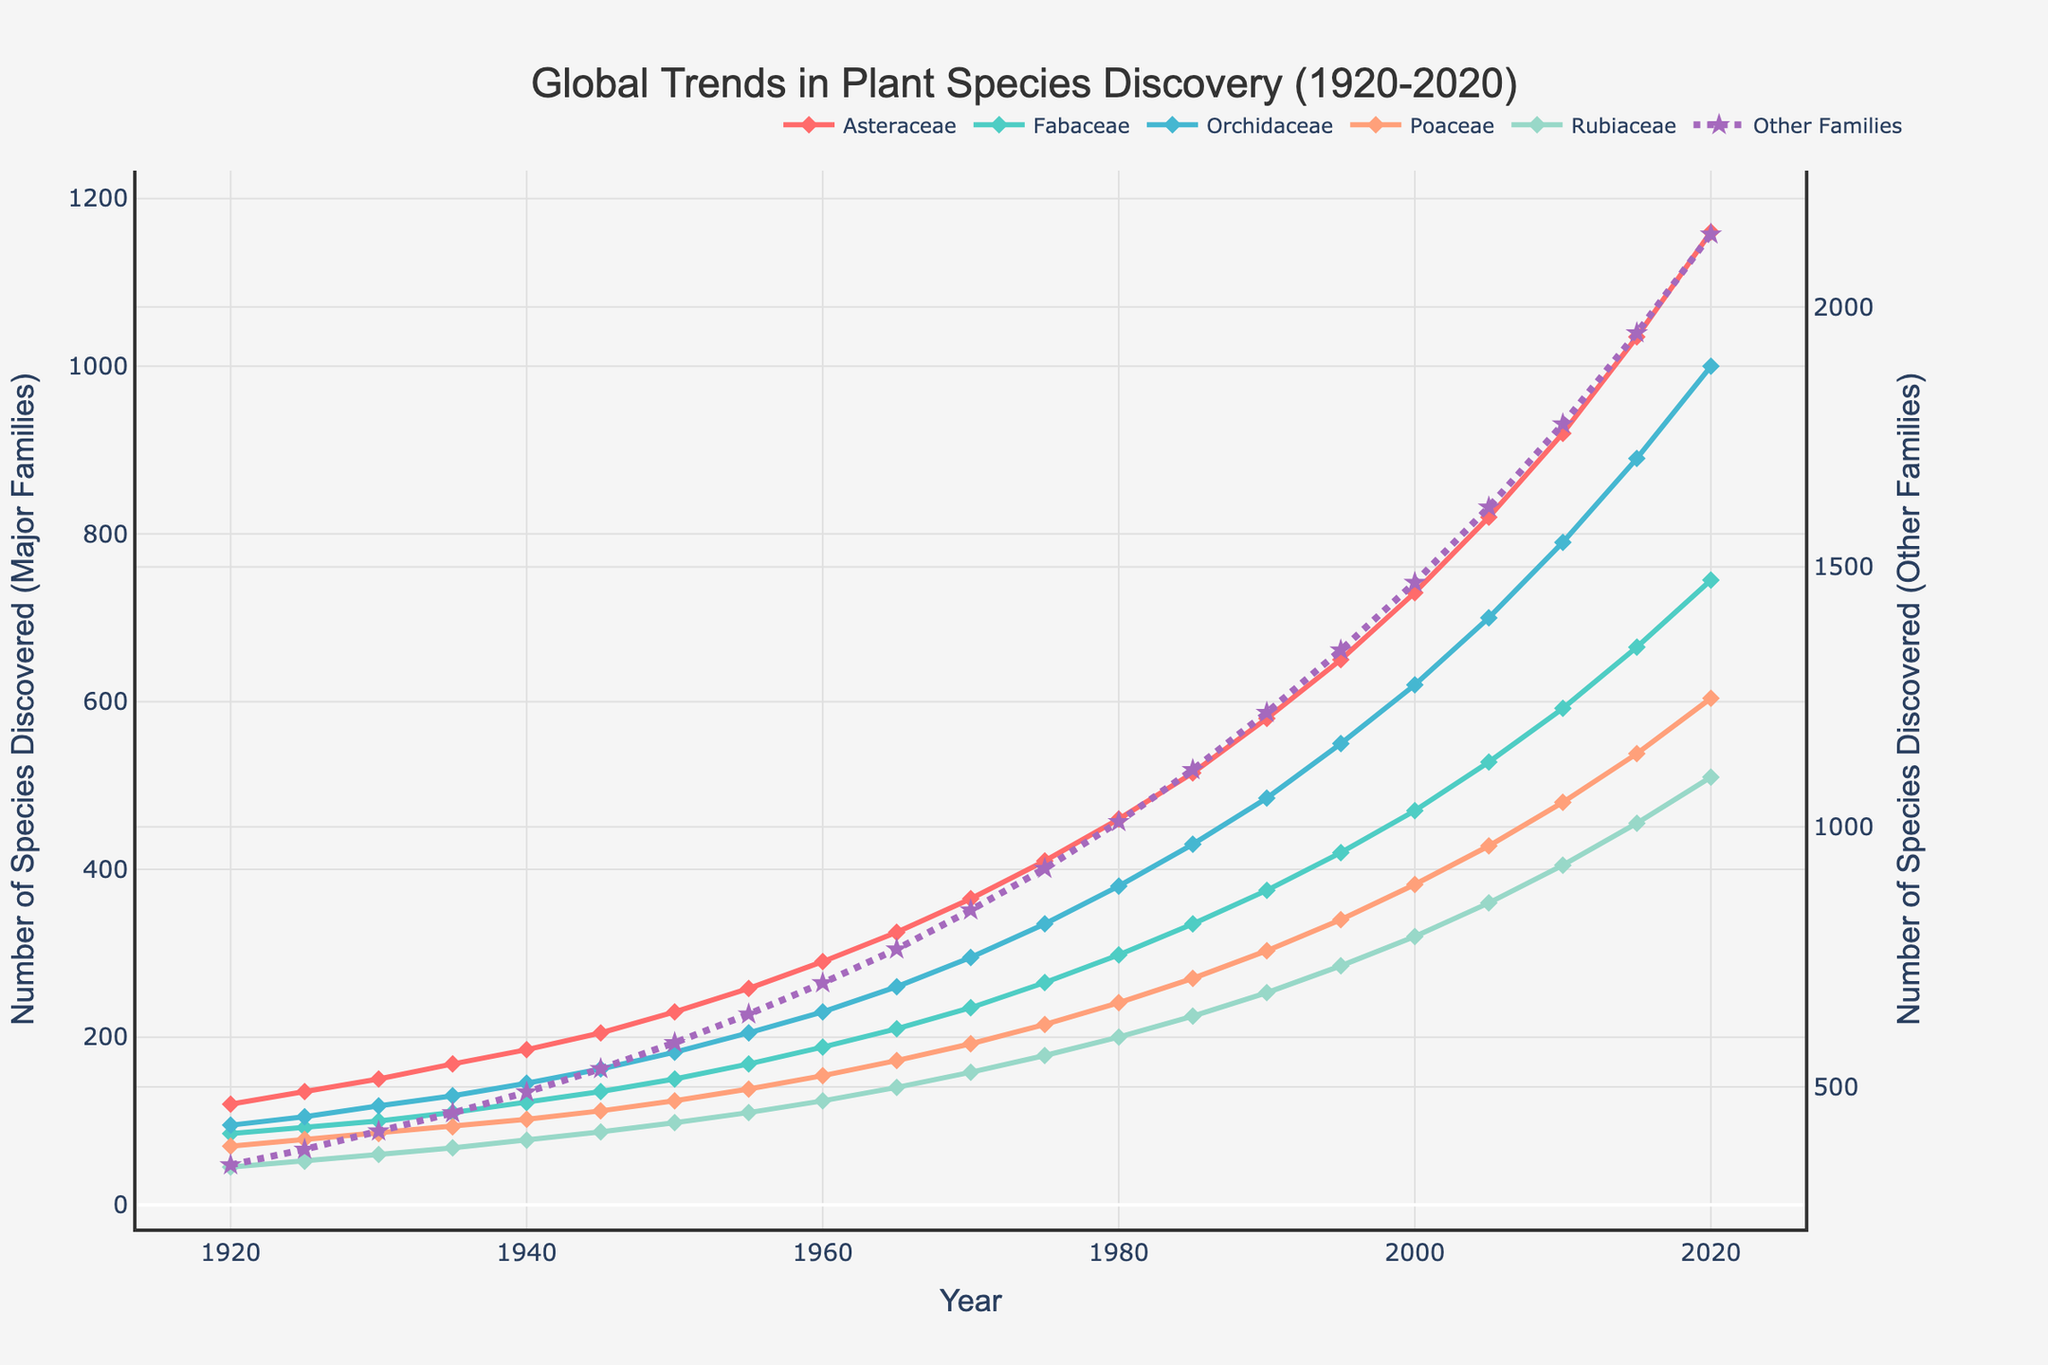What is the trend of species discovery for the Asteraceae family from 1920 to 2020? To find the trend, look at the plotted line for the Asteraceae family. The number of species discovered starts at 120 in 1920 and rises steadily to 1160 in 2020, indicating a consistent upward trend in discoveries.
Answer: Upward trend In which year does the Fabaceae family surpass 500 species discoveries for the first time? Check the plotted line for Fabaceae. Around 2005, the species discovered exceed 500 for the first time, as the value jumps to 528.
Answer: 2005 Which plant family shows the most significant increase in species discoveries between 1920 and 2020? For each family, calculate the increase by subtracting the 1920 value from the 2020 value. Asteraceae: 1160-120 = 1040, Fabaceae: 745-85 = 660, Orchidaceae: 1000-95 = 905, Poaceae: 604-70 = 534, Rubiaceae: 510-45 = 465, Other Families: 2140-350 = 1790. The family with the largest increase is "Other Families".
Answer: Other Families Compare the number of species discovered in 1950 and 2000 for the Orchidaceae family. By how much did the discoveries increase? Find the number of species discovered for 1950 and 2000 in the Orchidaceae family and calculate the difference. In 1950 it is 182, and in 2000 it is 620. The increase is 620 - 182 = 438.
Answer: 438 Which families had over 1000 species discovered by the year 2020? Check the data values for each family in the year 2020. Asteraceae with 1160, Orchidaceae with 1000, and Other Families with 2140 exceed 1000.
Answer: Asteraceae, Orchidaceae, Other Families During which decade did the Poaceae family experience the greatest number of discoveries? Look at the increments in the Poaceae discovery numbers between each decade and find the decade with the largest increase. 1960-1970 shows the highest increase of (192 - 124 = 68).
Answer: 1960-1970 What is the difference in the number of discovered species between Asteraceae and Fabaceae in 2020? Check the values for Asteraceae (1160) and Fabaceae (745) in 2020, then subtract Fabaceae from Asteraceae. 1160 - 745 = 415
Answer: 415 By how much did the discoveries in "Other Families" increase from 1980 to 1990? Find the difference between the discoveries in 1990 (1220) and 1980 (1010) for Other Families. The increase is 1220 - 1010 = 210.
Answer: 210 Which family showed a more significant increase in species discovery between 1970 and 2020, Orchidaceae or Rubiaceae? Calculate the increase for both families between 1970 and 2020. Orchidaceae increased from 295 to 1000 (1000-295=705). Rubiaceae increased from 158 to 510 (510-158=352). The greater increase is seen in Orchidaceae.
Answer: Orchidaceae 